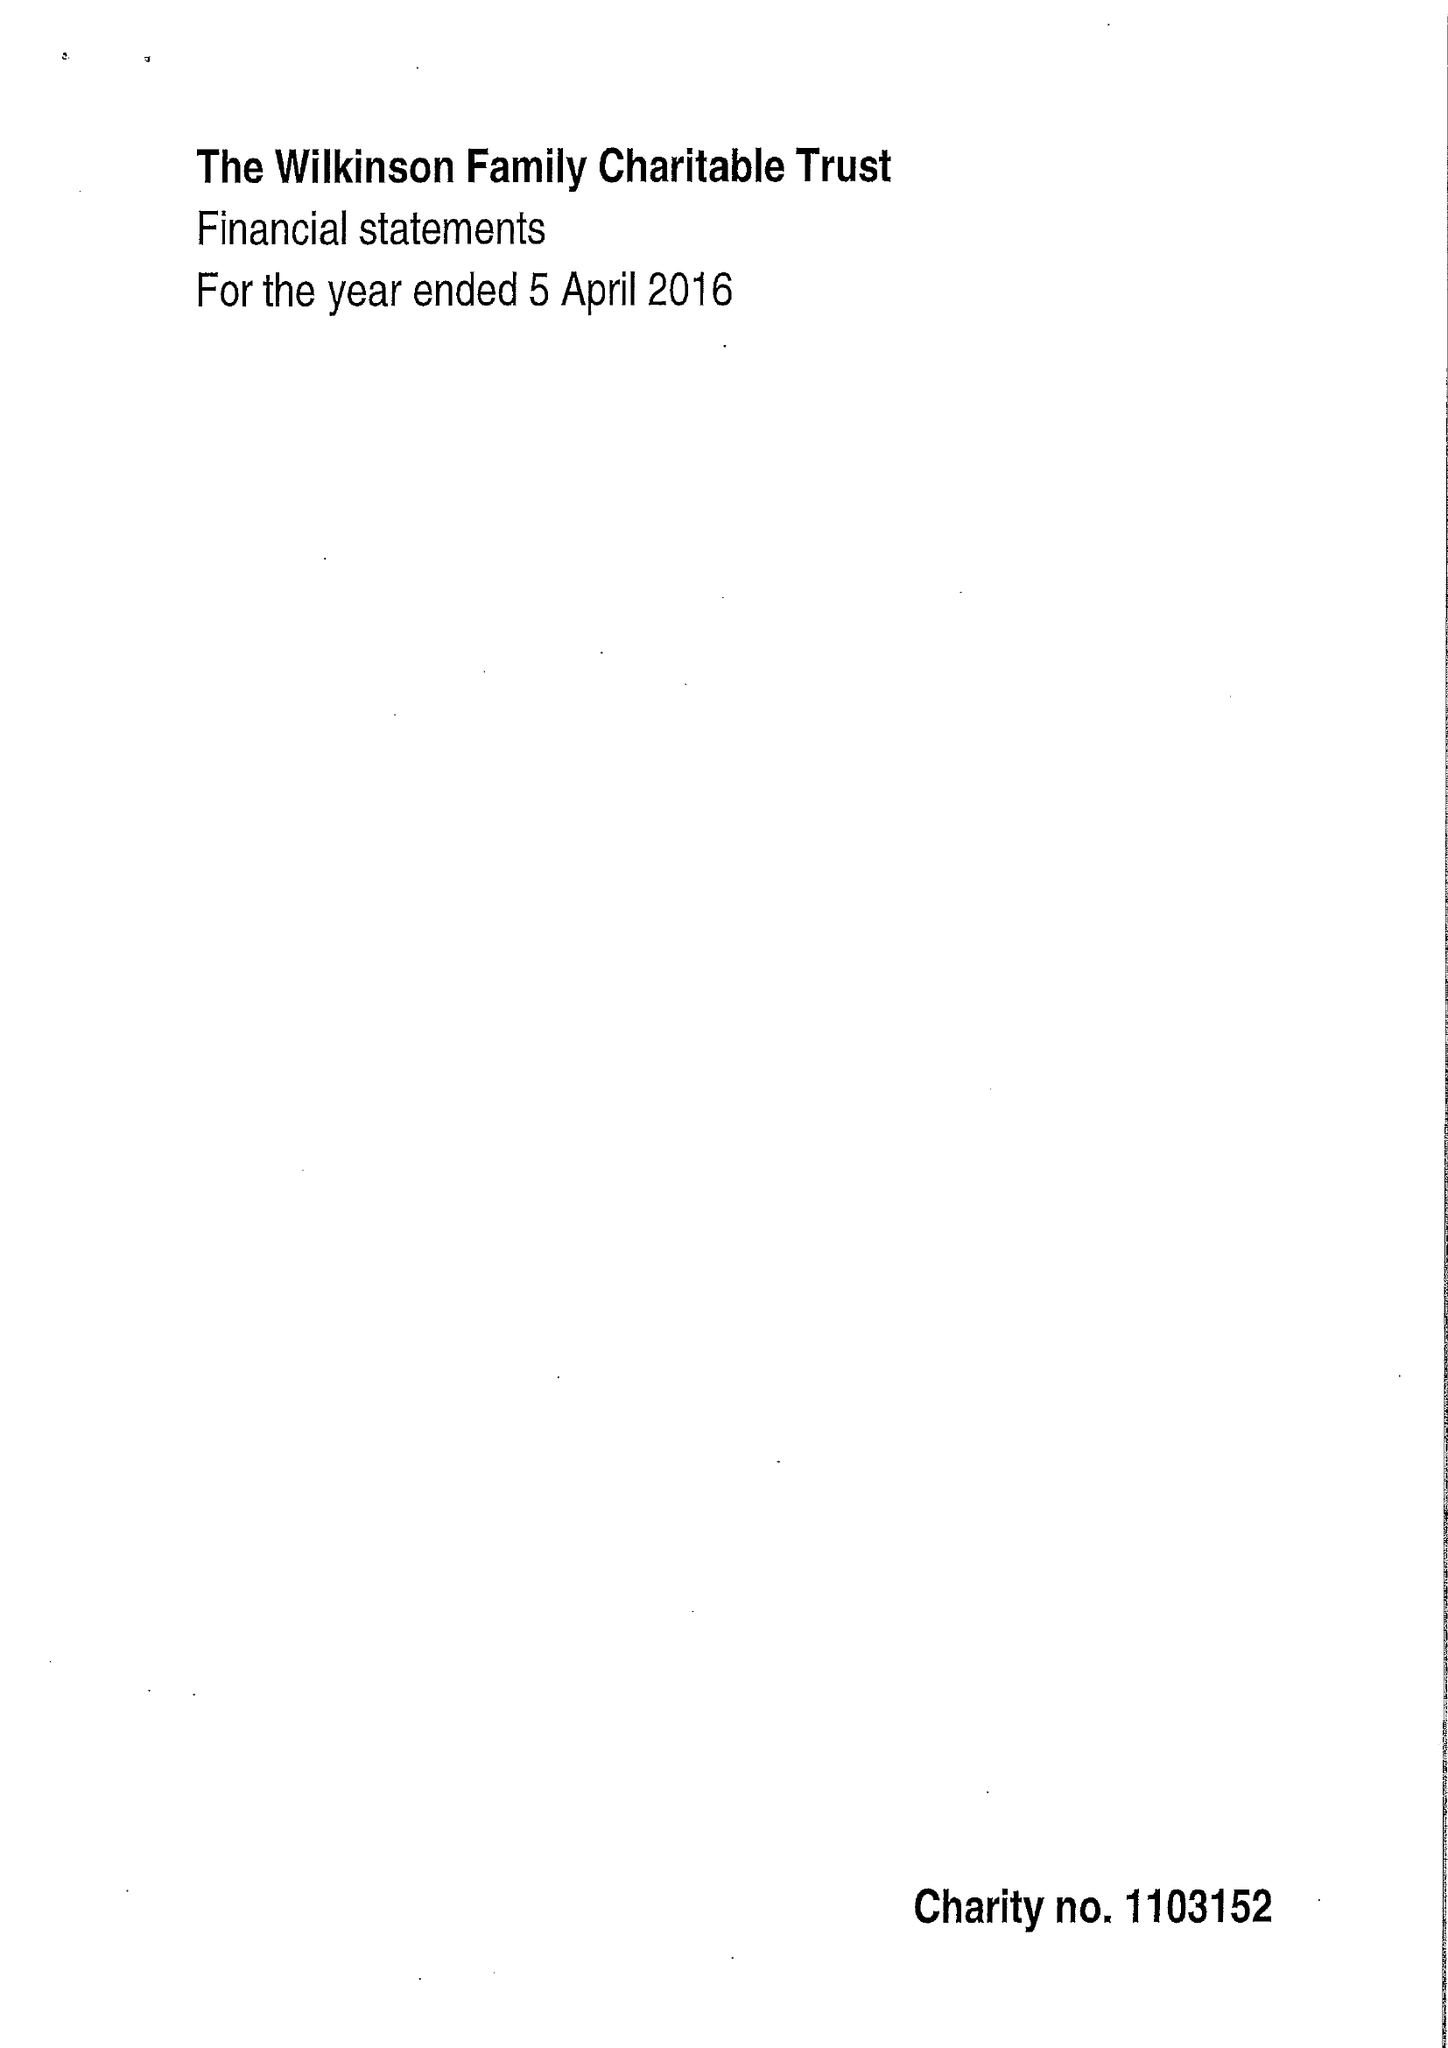What is the value for the address__post_town?
Answer the question using a single word or phrase. NOTTINGHAM 